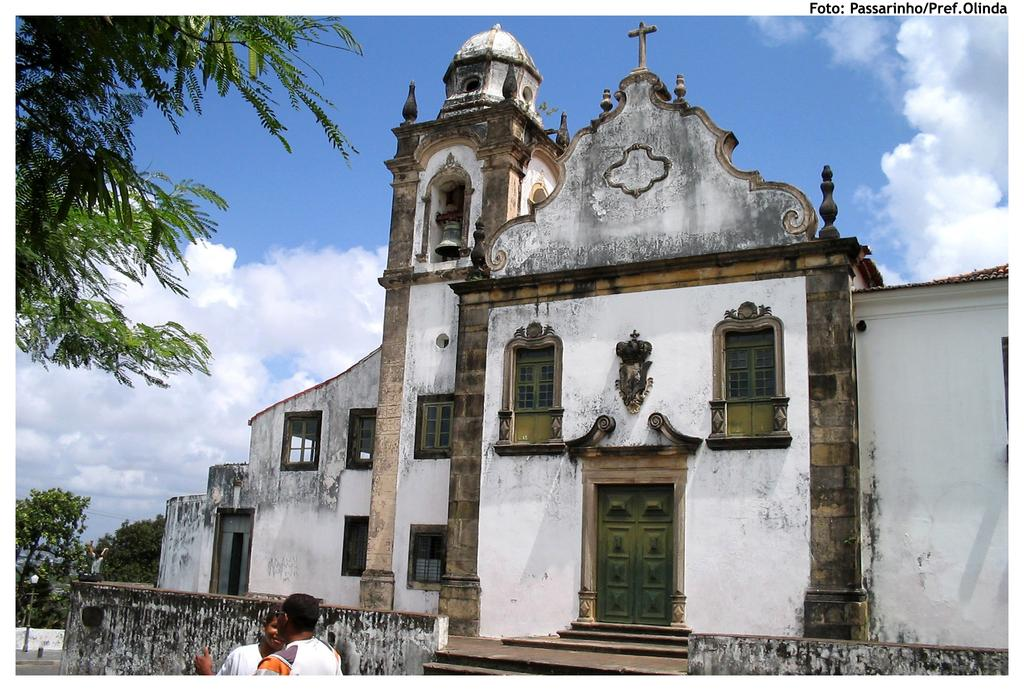How many people are in the image? There are two persons standing in the image. What can be seen in the background of the image? There is a building with brown and white colors, a light pole, trees with green color, and the sky with white and blue colors in the background. What type of jellyfish can be seen swimming in the sky in the image? There are no jellyfish present in the image, and the sky does not have any water for jellyfish to swim in. 